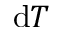<formula> <loc_0><loc_0><loc_500><loc_500>d T</formula> 